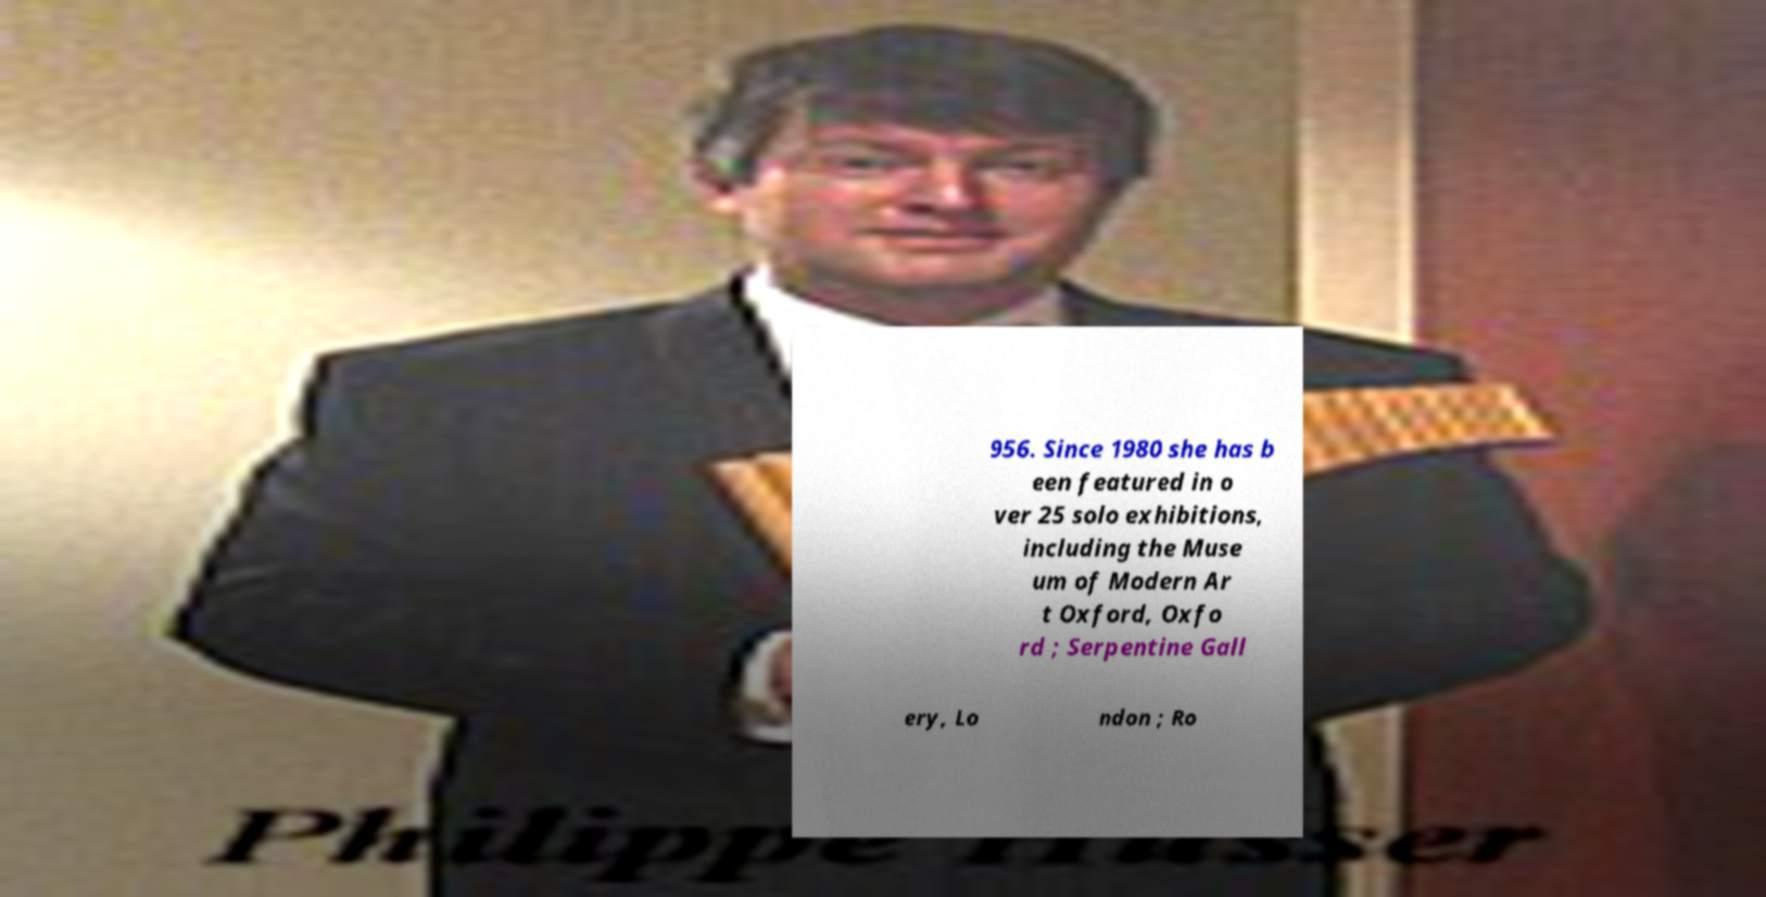I need the written content from this picture converted into text. Can you do that? 956. Since 1980 she has b een featured in o ver 25 solo exhibitions, including the Muse um of Modern Ar t Oxford, Oxfo rd ; Serpentine Gall ery, Lo ndon ; Ro 